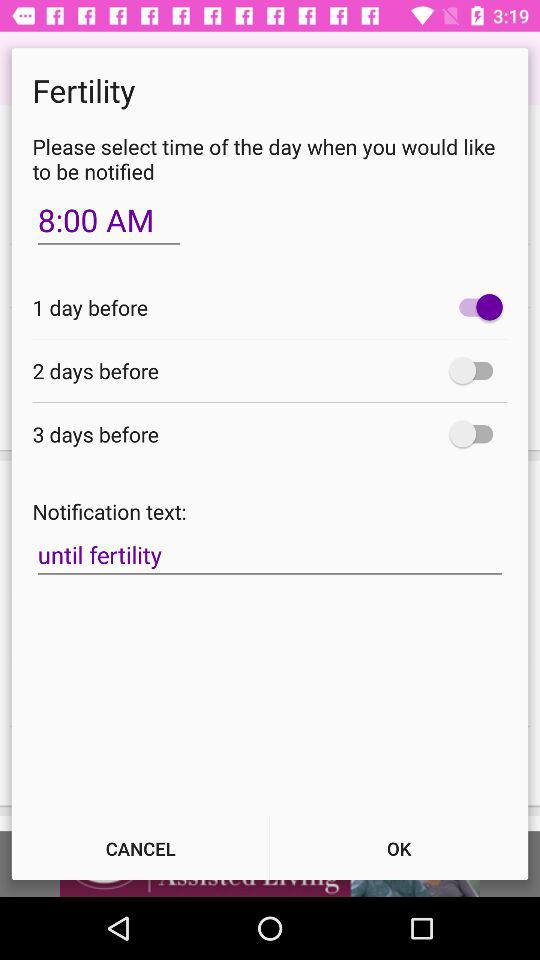What is the status of "1 day before"? The status of "1 day before" is "on". 